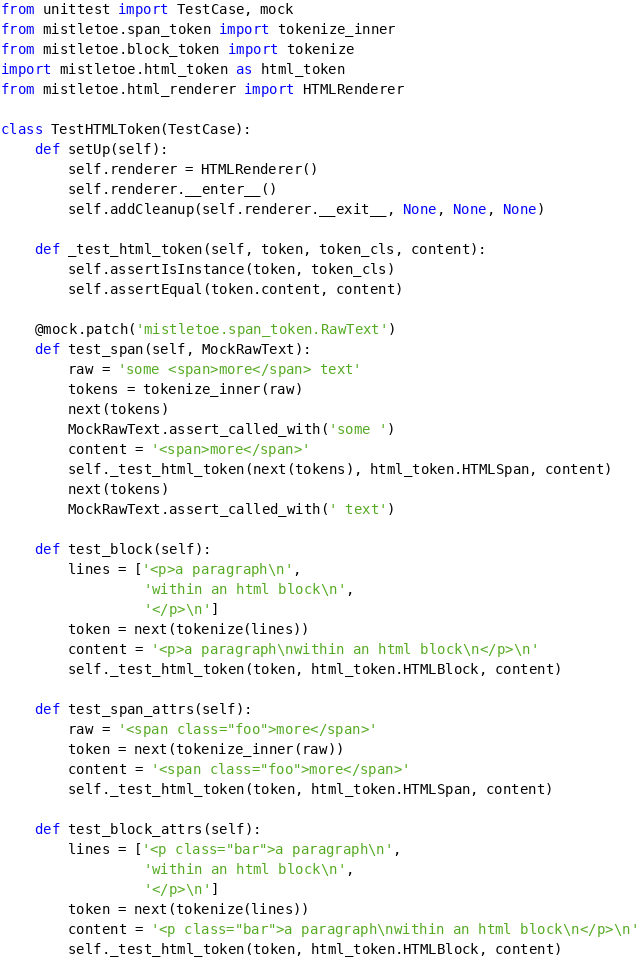<code> <loc_0><loc_0><loc_500><loc_500><_Python_>from unittest import TestCase, mock
from mistletoe.span_token import tokenize_inner
from mistletoe.block_token import tokenize
import mistletoe.html_token as html_token
from mistletoe.html_renderer import HTMLRenderer

class TestHTMLToken(TestCase):
    def setUp(self):
        self.renderer = HTMLRenderer()
        self.renderer.__enter__()
        self.addCleanup(self.renderer.__exit__, None, None, None)

    def _test_html_token(self, token, token_cls, content):
        self.assertIsInstance(token, token_cls)
        self.assertEqual(token.content, content)

    @mock.patch('mistletoe.span_token.RawText')
    def test_span(self, MockRawText):
        raw = 'some <span>more</span> text'
        tokens = tokenize_inner(raw)
        next(tokens)
        MockRawText.assert_called_with('some ')
        content = '<span>more</span>'
        self._test_html_token(next(tokens), html_token.HTMLSpan, content)
        next(tokens)
        MockRawText.assert_called_with(' text')

    def test_block(self):
        lines = ['<p>a paragraph\n',
                 'within an html block\n',
                 '</p>\n']
        token = next(tokenize(lines))
        content = '<p>a paragraph\nwithin an html block\n</p>\n'
        self._test_html_token(token, html_token.HTMLBlock, content)

    def test_span_attrs(self):
        raw = '<span class="foo">more</span>'
        token = next(tokenize_inner(raw))
        content = '<span class="foo">more</span>'
        self._test_html_token(token, html_token.HTMLSpan, content)

    def test_block_attrs(self):
        lines = ['<p class="bar">a paragraph\n',
                 'within an html block\n',
                 '</p>\n']
        token = next(tokenize(lines))
        content = '<p class="bar">a paragraph\nwithin an html block\n</p>\n'
        self._test_html_token(token, html_token.HTMLBlock, content)
</code> 